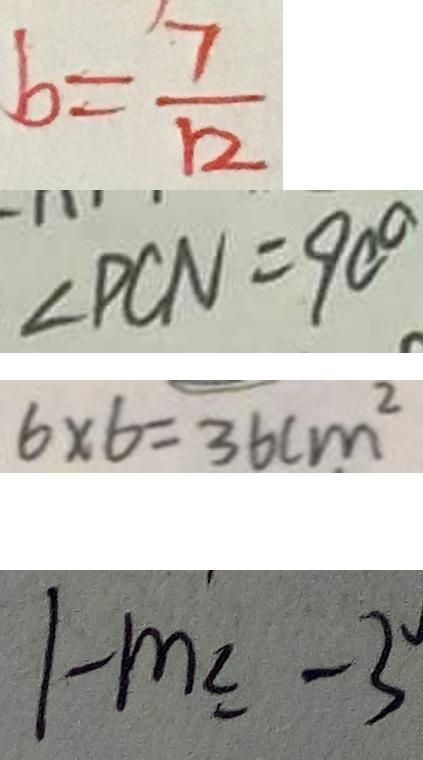Convert formula to latex. <formula><loc_0><loc_0><loc_500><loc_500>b = \frac { 7 } { 1 2 } 
 \angle P C N = 9 0 ^ { \circ } 
 6 \times 6 = 3 6 c m ^ { 2 } 
 1 - m \leq - 3</formula> 